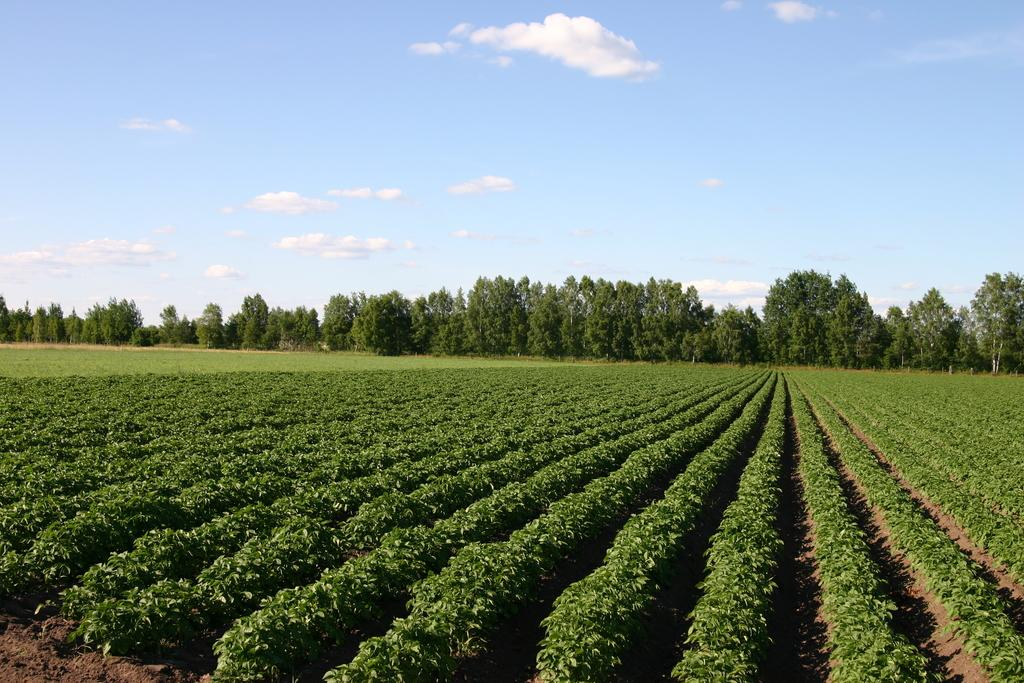What type of living organisms can be seen in the image? Plants and trees are visible in the image. What color are the plants and trees in the image? The plants and trees are in green color. What can be seen in the background of the image? The sky is visible in the background of the image. What colors are present in the sky in the image? The sky has white and blue colors. What type of tin can be seen in the image? There is no tin present in the image. What action are the straws performing in the image? There are no straws present in the image, so no action involving straws can be observed. 